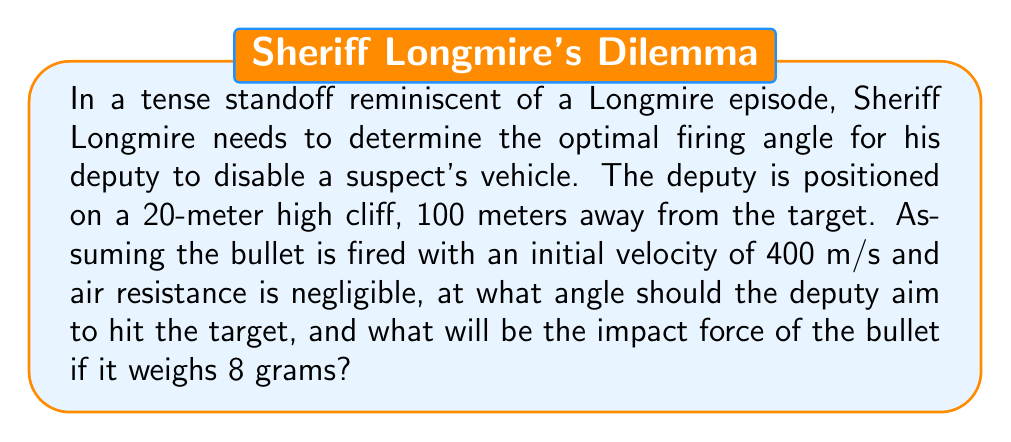Give your solution to this math problem. To solve this problem, we'll use principles of projectile motion and impact force calculation.

1. First, let's determine the optimal angle:

The trajectory of the bullet follows the equation:

$$y = x \tan \theta - \frac{gx^2}{2v_0^2 \cos^2 \theta}$$

Where:
$y$ is the vertical displacement (20 m)
$x$ is the horizontal displacement (100 m)
$\theta$ is the angle of projection
$g$ is the acceleration due to gravity (9.8 m/s²)
$v_0$ is the initial velocity (400 m/s)

Substituting the known values:

$$20 = 100 \tan \theta - \frac{9.8 \cdot 100^2}{2 \cdot 400^2 \cos^2 \theta}$$

Solving this equation numerically (as it's too complex for an algebraic solution), we get:

$$\theta \approx 11.78°$$

2. Now, let's calculate the impact force:

The time of flight can be calculated using:

$$t = \frac{2v_0 \sin \theta}{g}$$

$$t = \frac{2 \cdot 400 \cdot \sin(11.78°)}{9.8} \approx 1.67 \text{ seconds}$$

The final velocity just before impact:

$$v_f = \sqrt{v_0^2 + 2gh}$$
$$v_f = \sqrt{400^2 + 2 \cdot 9.8 \cdot 20} \approx 400.49 \text{ m/s}$$

The change in momentum:

$$\Delta p = mv_f - mv_0 = 0.008 \cdot (400.49 - 400) = 0.00392 \text{ kg·m/s}$$

Assuming the impact duration is very short, say 0.001 seconds, the impact force is:

$$F = \frac{\Delta p}{\Delta t} = \frac{0.00392}{0.001} = 3.92 \text{ N}$$
Answer: The deputy should aim at an angle of approximately 11.78° above the horizontal. The impact force of the bullet will be about 3.92 N. 